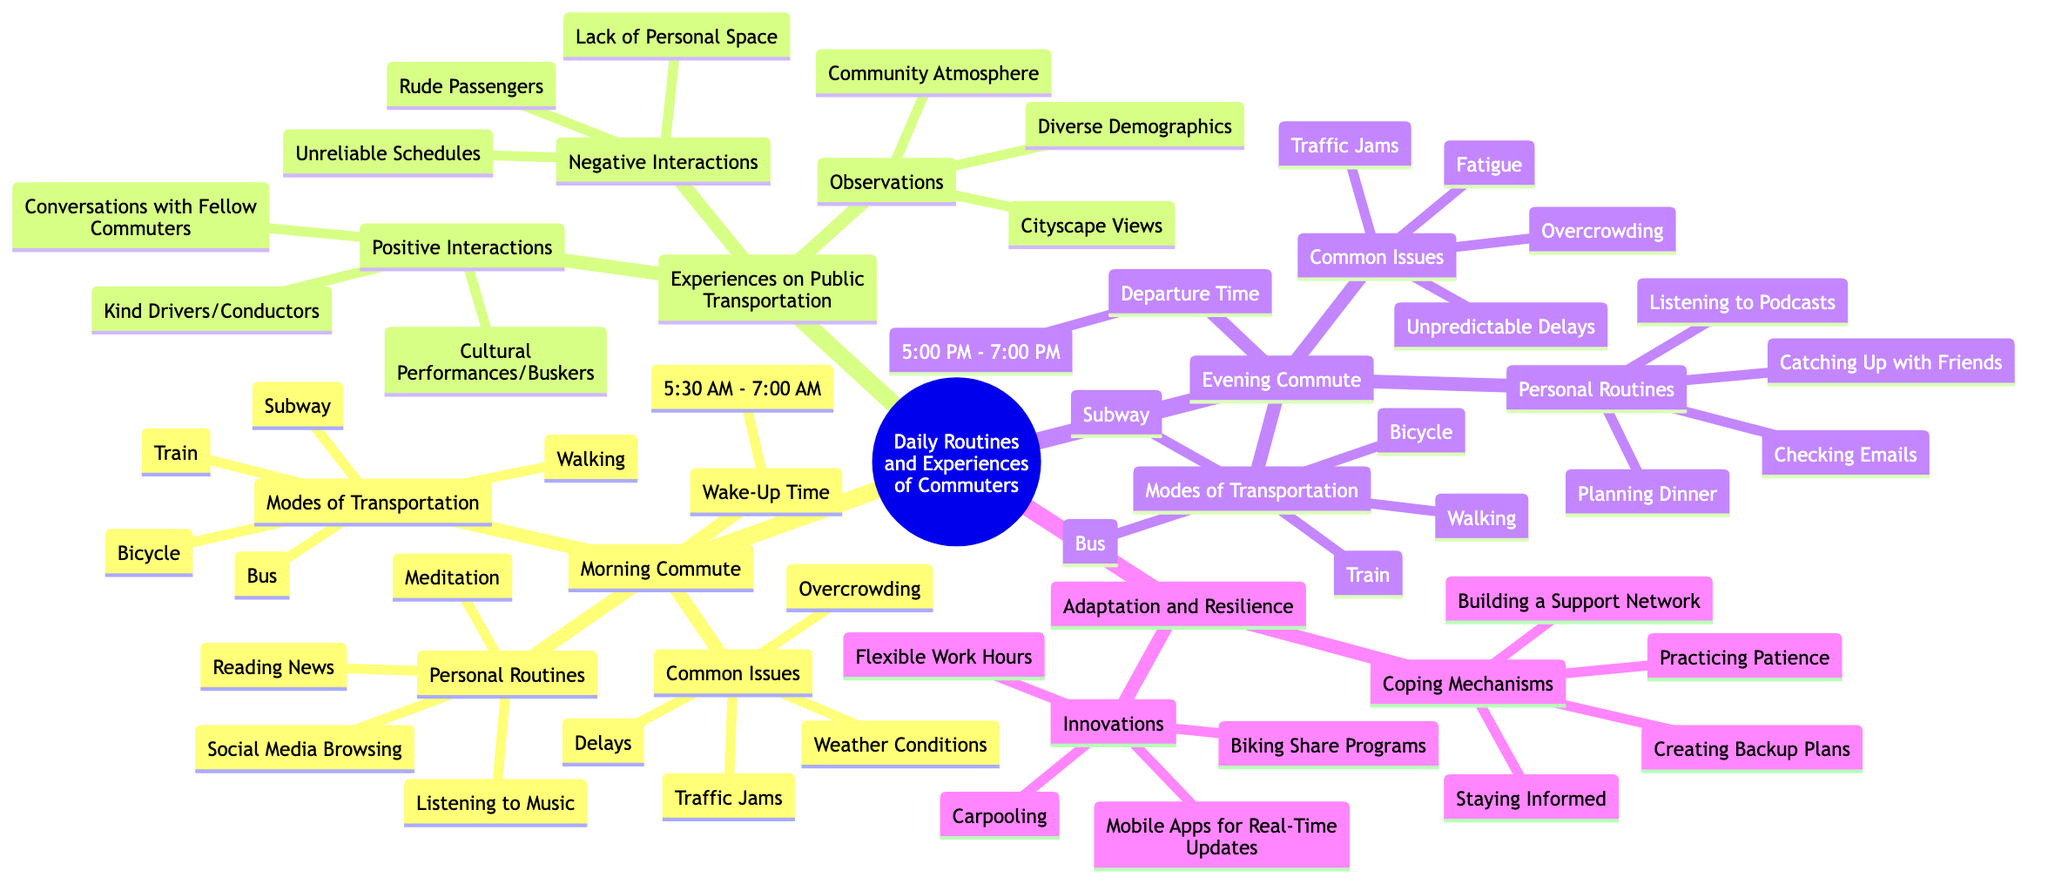What is the wake-up time range for the morning commute? The node under "Morning Commute" specifies the wake-up time, listed as "5:30 AM - 7:00 AM." Therefore, this range is the answer.
Answer: 5:30 AM - 7:00 AM How many modes of transportation are listed under the morning commute? By counting the items in the "Modes of Transportation" section under "Morning Commute," we find there are five options (Bus, Train, Subway, Bicycle, Walking).
Answer: 5 What are two common issues faced during the evening commute? The "Common Issues" section under "Evening Commute" lists several items. Selecting any two of them, such as "Fatigue" and "Traffic Jams," will suffice as valid answers.
Answer: Fatigue, Traffic Jams What coping mechanism involves creating alternative plans? The "Coping Mechanisms" section in "Adaptation and Resilience" includes "Creating Backup Plans" as one of the mechanisms that relates to planning for unexpected events.
Answer: Creating Backup Plans What are the positive interactions experienced on public transportation? The "Positive Interactions" section lists specific experiences that include "Conversations with Fellow Commuters," "Kind Drivers/Conductors," and "Cultural Performances/Buskers." The answer requires citing these interactions.
Answer: Conversations with Fellow Commuters, Kind Drivers/Conductors, Cultural Performances/Buskers Which personal routine is found in both morning and evening commutes? One of the personal routines under "Morning Commute" is "Listening to Music," as well as listening to "Podcasts" under "Evening Commute." However, only "Listening to Music" appears explicitly in the morning section; hence we look for an exact match. In this case, there isn't a direct common element without overlap in the specific wording. Therefore, the answer would be none since they are distinct.
Answer: None What time frame defines evening commute departure? The departure time during the evening commute is stated as "5:00 PM - 7:00 PM." This is explicitly mentioned in the "Evening Commute" section of the mind map.
Answer: 5:00 PM - 7:00 PM Identify one negative interaction commonly faced on public transportation. In the "Negative Interactions" section of the "Experiences on Public Transportation" section, "Rude Passengers" is listed among various negative experiences. Picking any item from that section will provide the answer.
Answer: Rude Passengers 